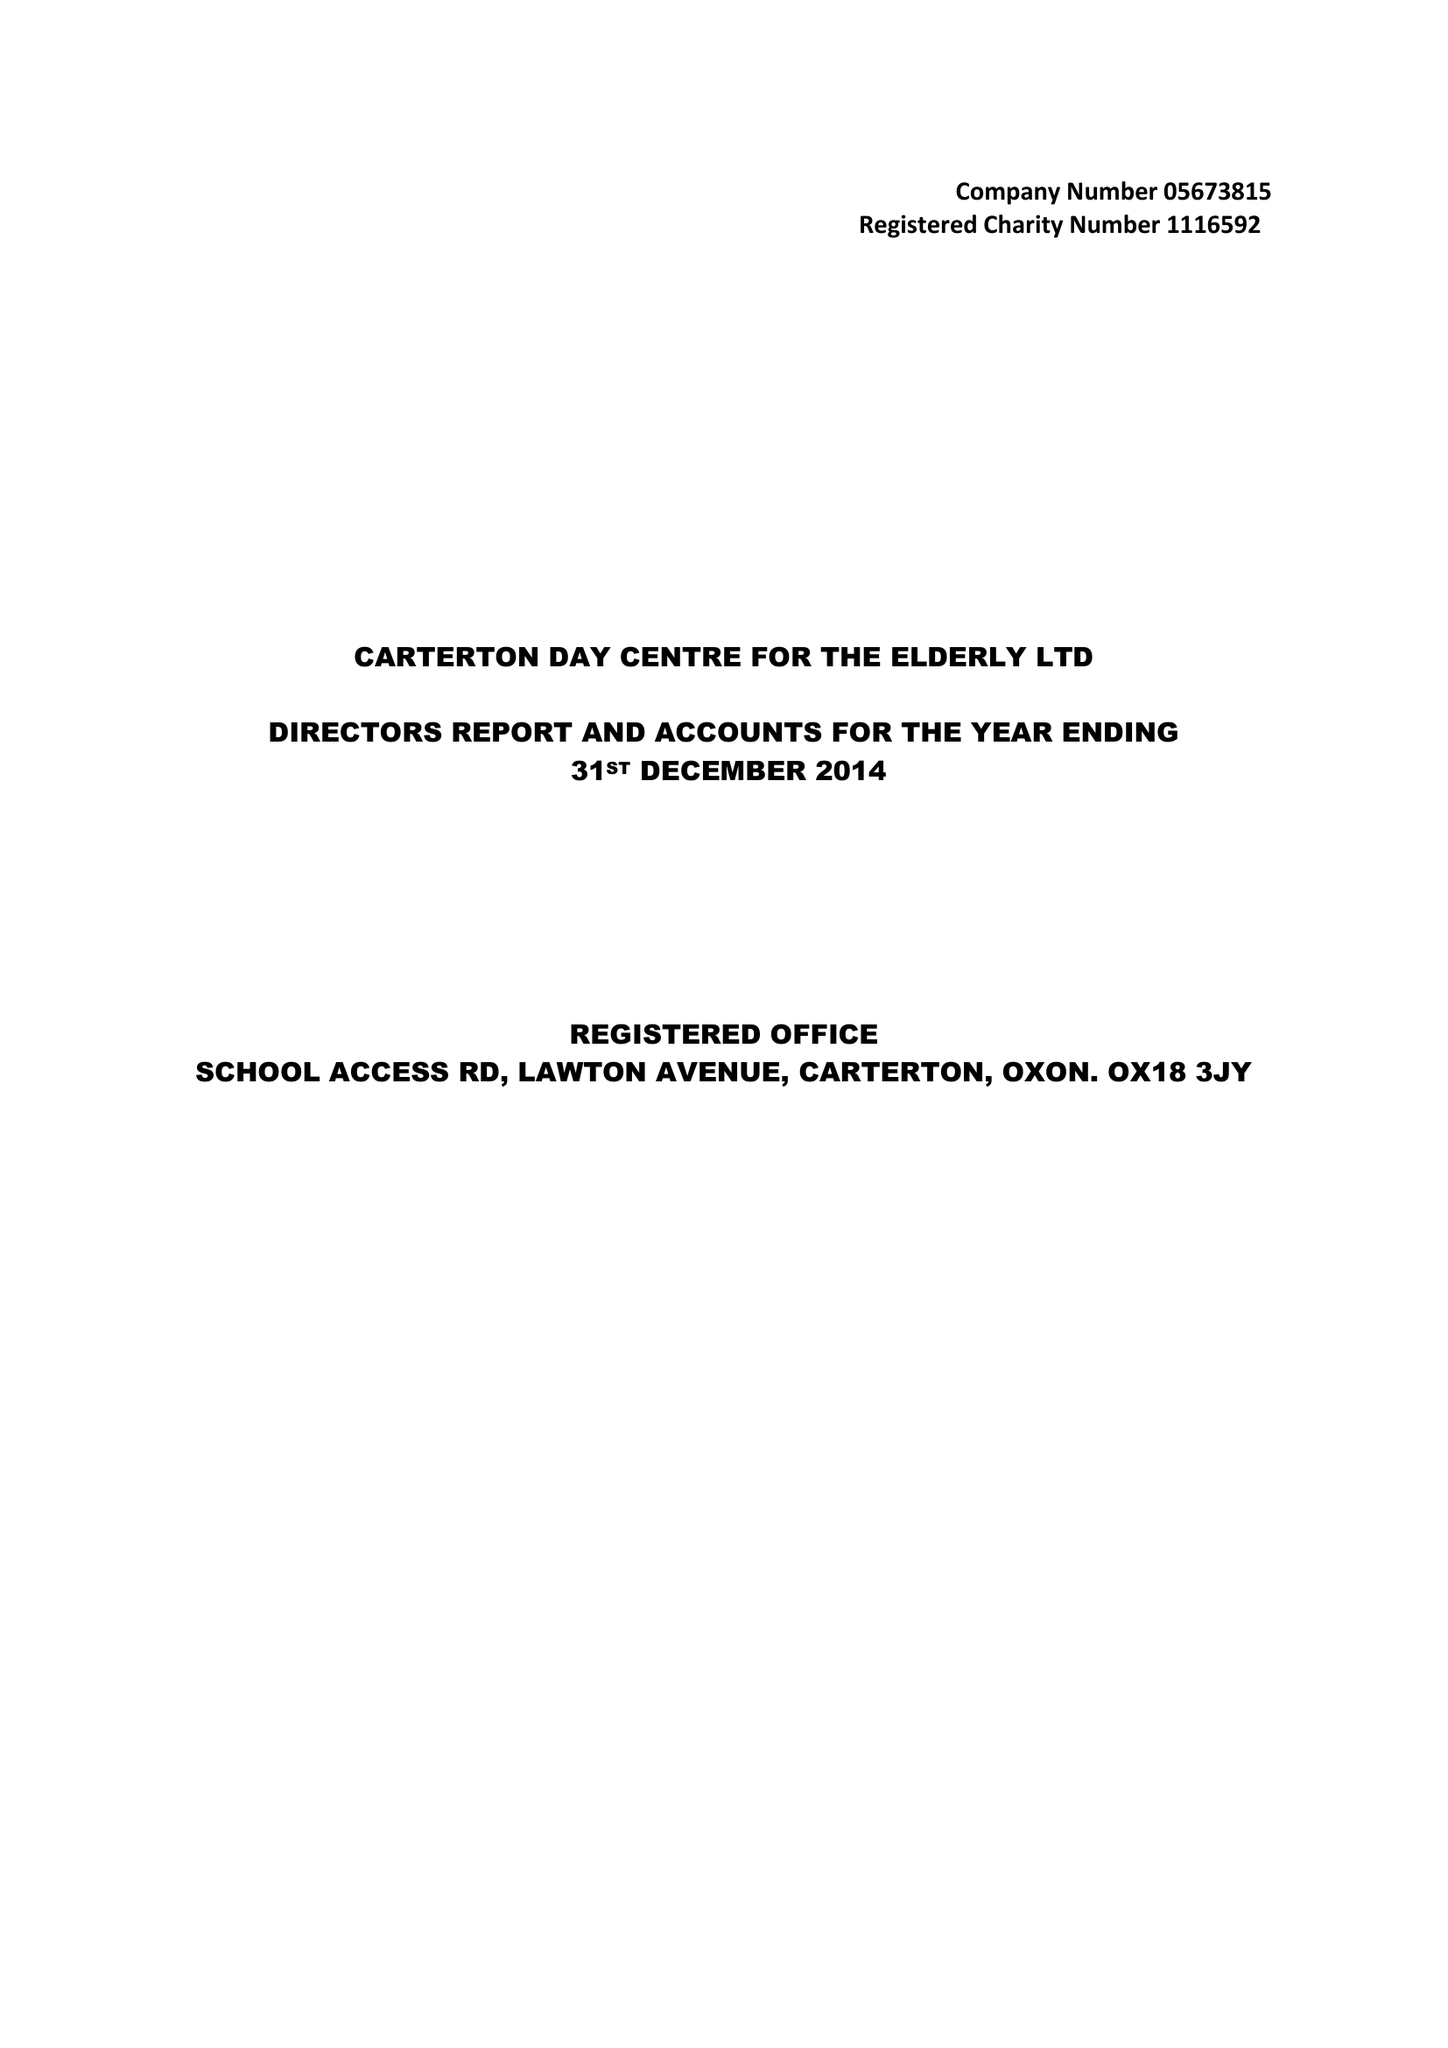What is the value for the spending_annually_in_british_pounds?
Answer the question using a single word or phrase. 38675.00 